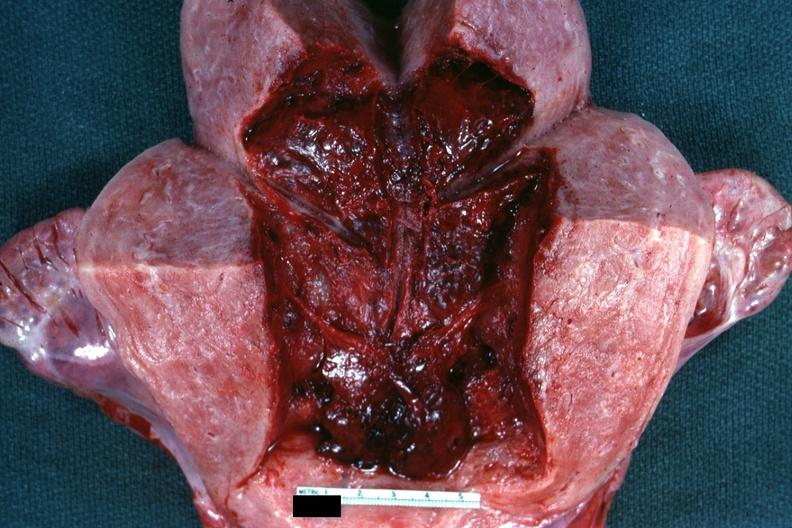what does this image show?
Answer the question using a single word or phrase. 18 hours after cesarean section 